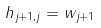<formula> <loc_0><loc_0><loc_500><loc_500>h _ { j + 1 , j } = \| w _ { j + 1 } \|</formula> 